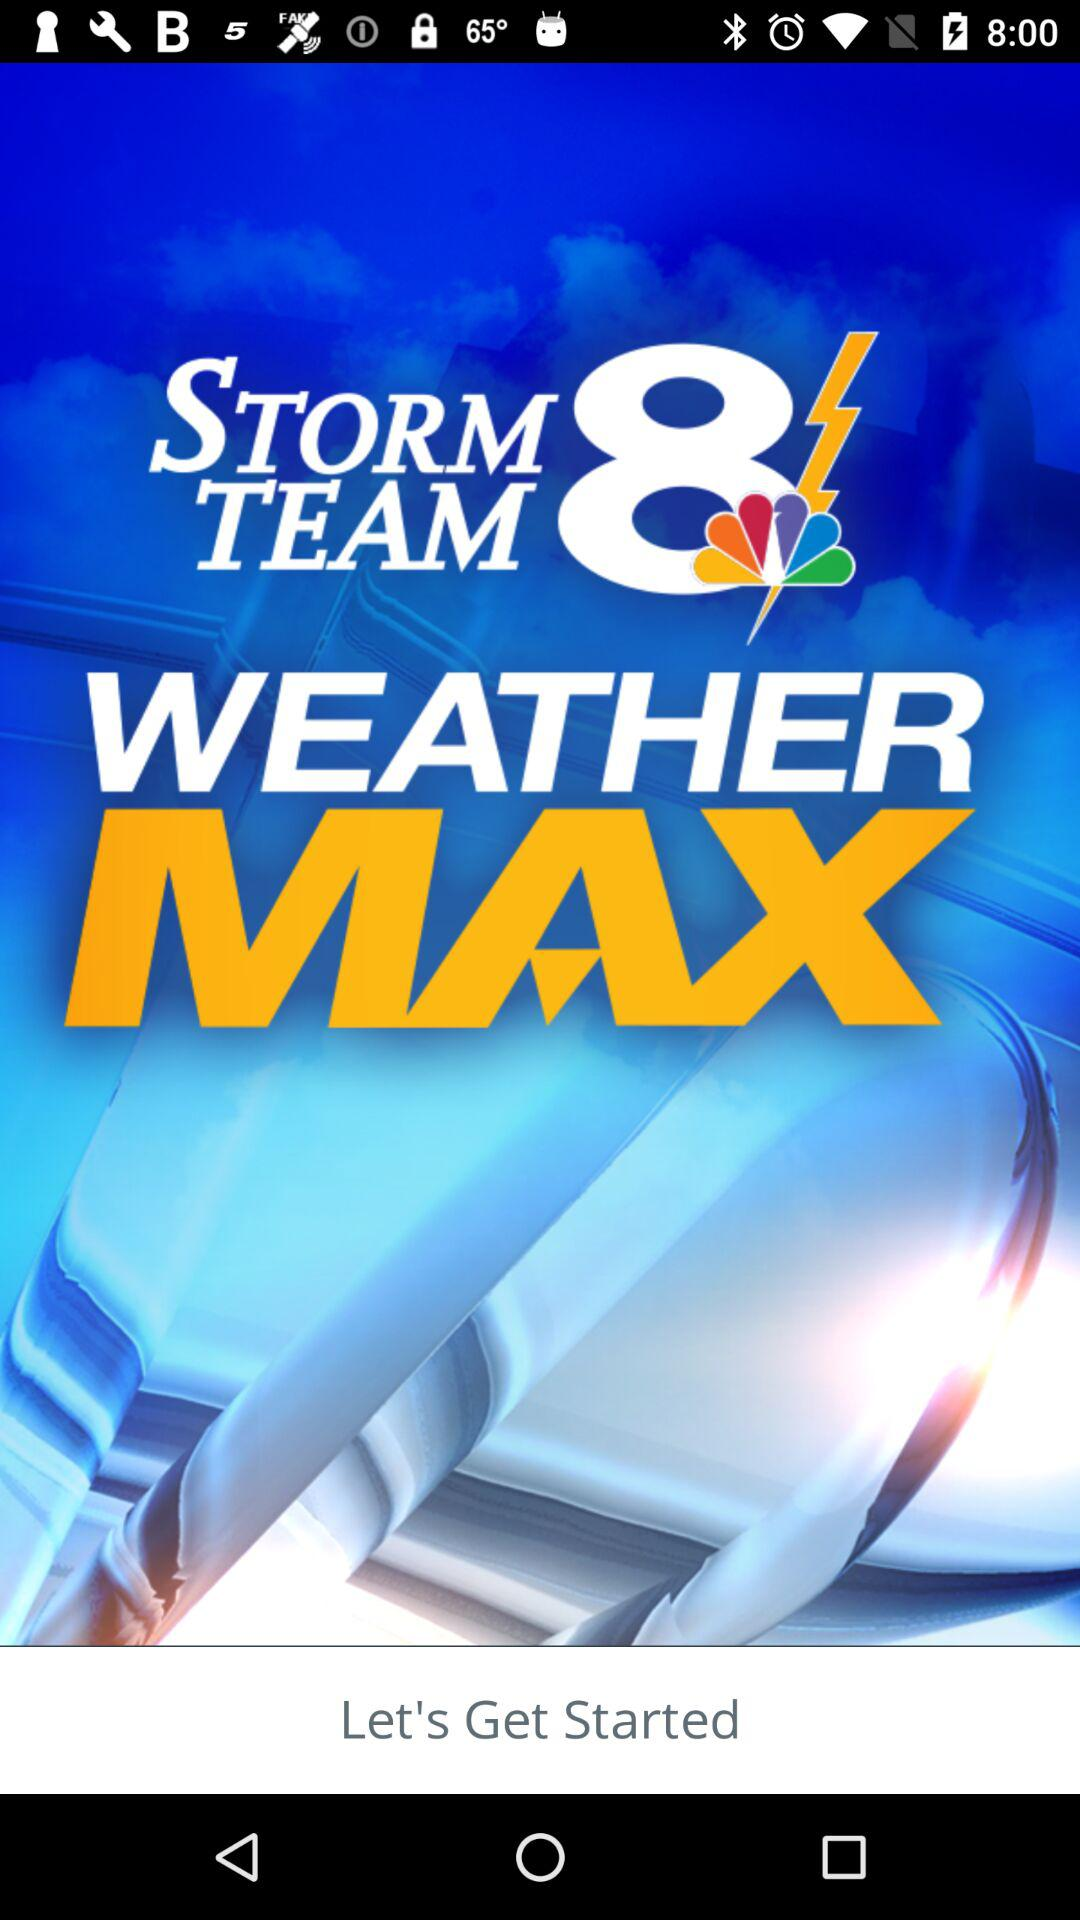What is the name of the application? The name of the application is "Storm Team 8 Weather MAX". 